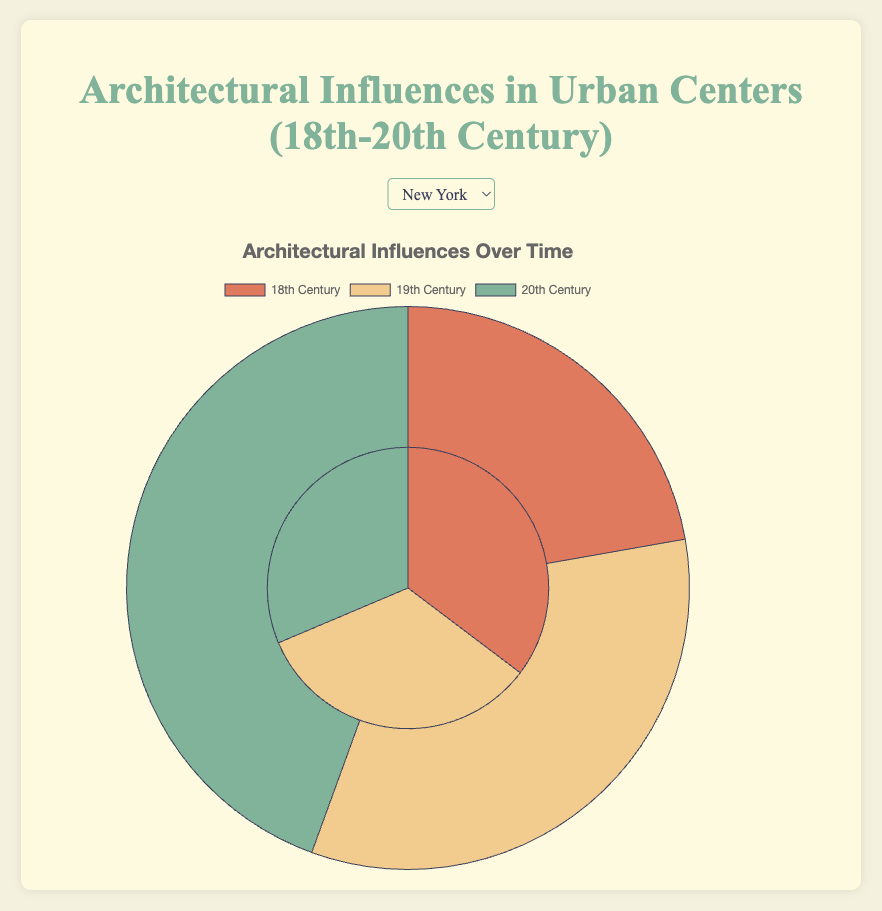What city had the highest increase in foreign influence from the 18th to the 20th century? Calculate the difference in foreign influence for each city between the 20th and 18th centuries. New York: 80 - 90 = -10, Paris: 60 - 30 = 30, Tokyo: 70 - 20 = 50, Cairo: 50 - 10 = 40, Mumbai: 65 - 25 = 40. Tokyo and Mumbai have the highest increase with a gain of 50 percentage points.
Answer: Tokyo and Mumbai Which city had an equal distribution of indigenous and foreign influences at any point? Check the data for each city across all time periods to see where indigenous and foreign influences are equal. The 19th century in Paris and the 20th century in Cairo have equal influences (50% each).
Answer: Paris (19th Century) and Cairo (20th Century) Which city consistently showed a higher proportion of indigenous influence compared to foreign influence across all time periods? Compare indigenous and foreign influences in all time periods for each city. Only Tokyo has consistently higher indigenous influence in the 18th century, but it decreases over time. No city consistently shows higher indigenous influence in all time periods.
Answer: None How did the indigenous influence in Cairo change between the 18th and 20th centuries? Track the indigenous influence percentages for Cairo across the different time periods provided. The values are 90% (18th), 70% (19th), and 50% (20th). This indicates a decrease.
Answer: Decreased Which city had the most balanced mix of indigenous and foreign influences in the 18th century? Evaluate the difference between indigenous and foreign influence for each city in the 18th century. The smallest difference indicates the most balanced mix. New York: 80, Paris: 40, Tokyo: 60, Cairo: 80, Mumbai: 50. Paris has the smallest difference (40).
Answer: Paris 